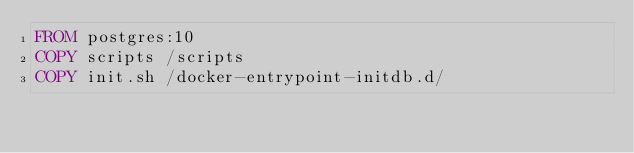<code> <loc_0><loc_0><loc_500><loc_500><_Dockerfile_>FROM postgres:10
COPY scripts /scripts
COPY init.sh /docker-entrypoint-initdb.d/</code> 